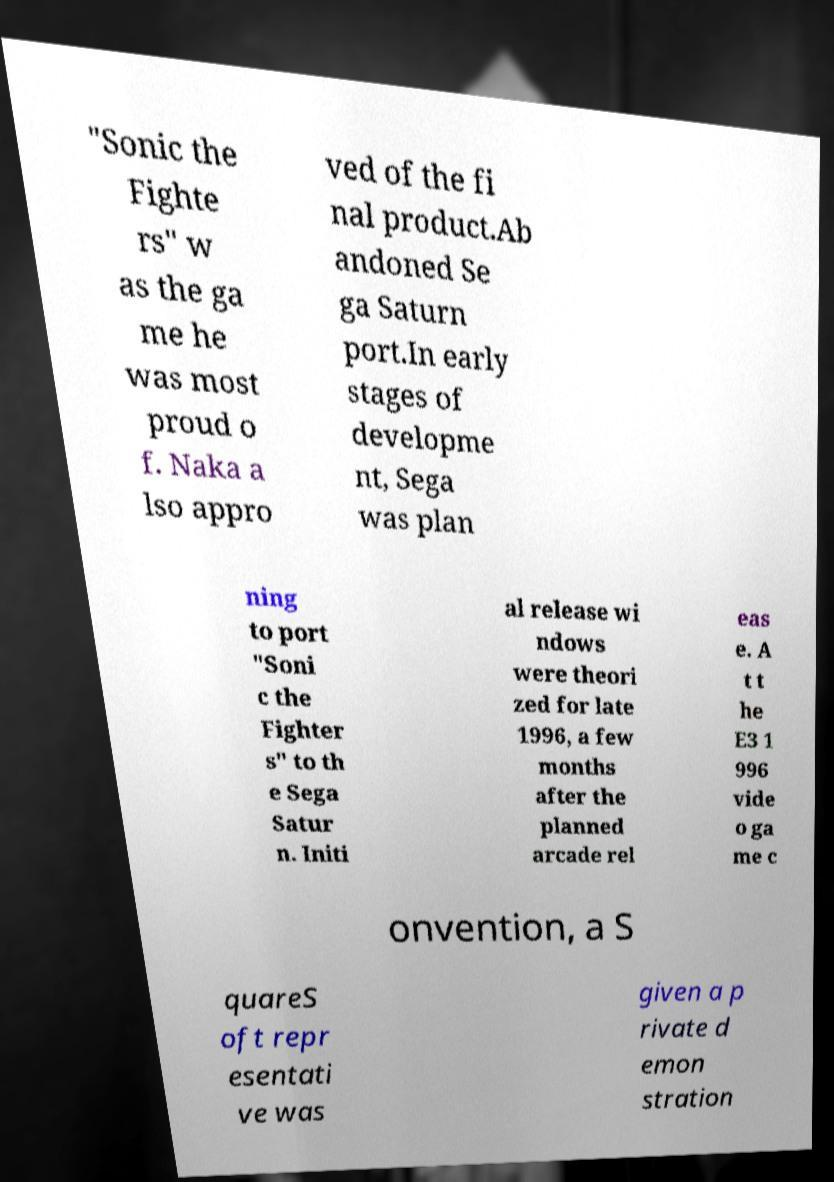There's text embedded in this image that I need extracted. Can you transcribe it verbatim? "Sonic the Fighte rs" w as the ga me he was most proud o f. Naka a lso appro ved of the fi nal product.Ab andoned Se ga Saturn port.In early stages of developme nt, Sega was plan ning to port "Soni c the Fighter s" to th e Sega Satur n. Initi al release wi ndows were theori zed for late 1996, a few months after the planned arcade rel eas e. A t t he E3 1 996 vide o ga me c onvention, a S quareS oft repr esentati ve was given a p rivate d emon stration 